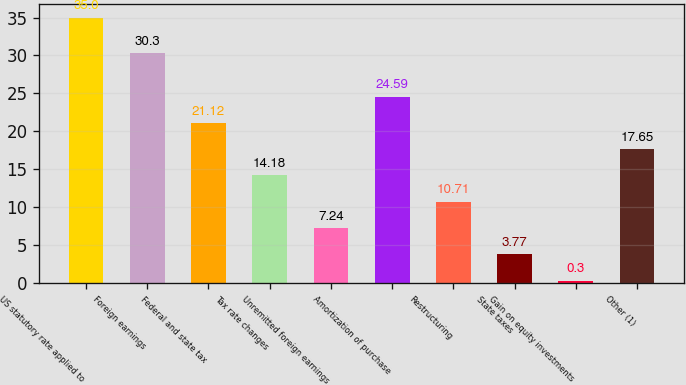Convert chart to OTSL. <chart><loc_0><loc_0><loc_500><loc_500><bar_chart><fcel>US statutory rate applied to<fcel>Foreign earnings<fcel>Federal and state tax<fcel>Tax rate changes<fcel>Unremitted foreign earnings<fcel>Amortization of purchase<fcel>Restructuring<fcel>State taxes<fcel>Gain on equity investments<fcel>Other (1)<nl><fcel>35<fcel>30.3<fcel>21.12<fcel>14.18<fcel>7.24<fcel>24.59<fcel>10.71<fcel>3.77<fcel>0.3<fcel>17.65<nl></chart> 